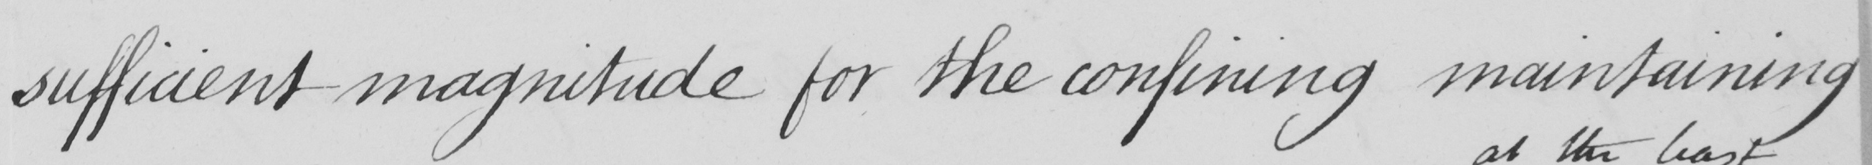Please transcribe the handwritten text in this image. sufficient magnitude for the confining maintaining 